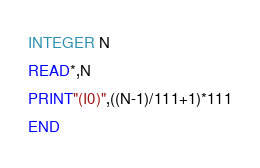Convert code to text. <code><loc_0><loc_0><loc_500><loc_500><_FORTRAN_>INTEGER N
READ*,N
PRINT"(I0)",((N-1)/111+1)*111
END</code> 